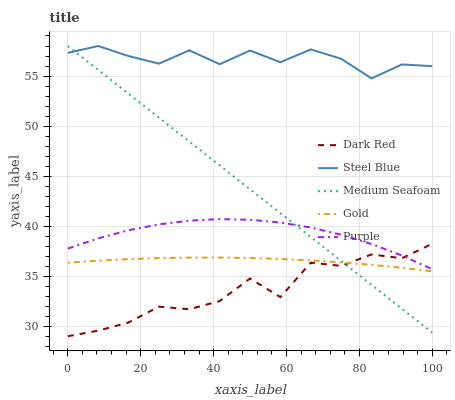Does Dark Red have the minimum area under the curve?
Answer yes or no. Yes. Does Steel Blue have the maximum area under the curve?
Answer yes or no. Yes. Does Steel Blue have the minimum area under the curve?
Answer yes or no. No. Does Dark Red have the maximum area under the curve?
Answer yes or no. No. Is Medium Seafoam the smoothest?
Answer yes or no. Yes. Is Dark Red the roughest?
Answer yes or no. Yes. Is Steel Blue the smoothest?
Answer yes or no. No. Is Steel Blue the roughest?
Answer yes or no. No. Does Steel Blue have the lowest value?
Answer yes or no. No. Does Medium Seafoam have the highest value?
Answer yes or no. Yes. Does Dark Red have the highest value?
Answer yes or no. No. Is Dark Red less than Steel Blue?
Answer yes or no. Yes. Is Purple greater than Gold?
Answer yes or no. Yes. Does Medium Seafoam intersect Gold?
Answer yes or no. Yes. Is Medium Seafoam less than Gold?
Answer yes or no. No. Is Medium Seafoam greater than Gold?
Answer yes or no. No. Does Dark Red intersect Steel Blue?
Answer yes or no. No. 